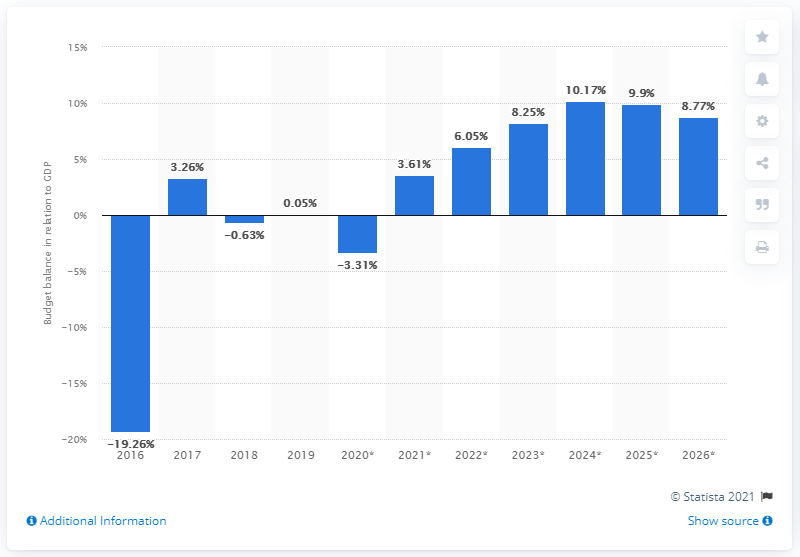Specify some key components in this picture. According to the 2019 budget surplus in South Sudan, it is estimated that only 0.05% of the country's GDP was accounted for. 